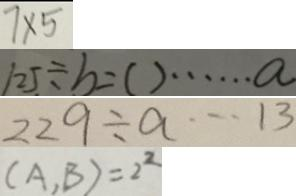Convert formula to latex. <formula><loc_0><loc_0><loc_500><loc_500>7 \times 5 
 1 2 5 \div b = ( ) \cdots a 
 2 2 9 \div a \cdots 1 3 
 ( A , B ) = 2 ^ { 2 }</formula> 